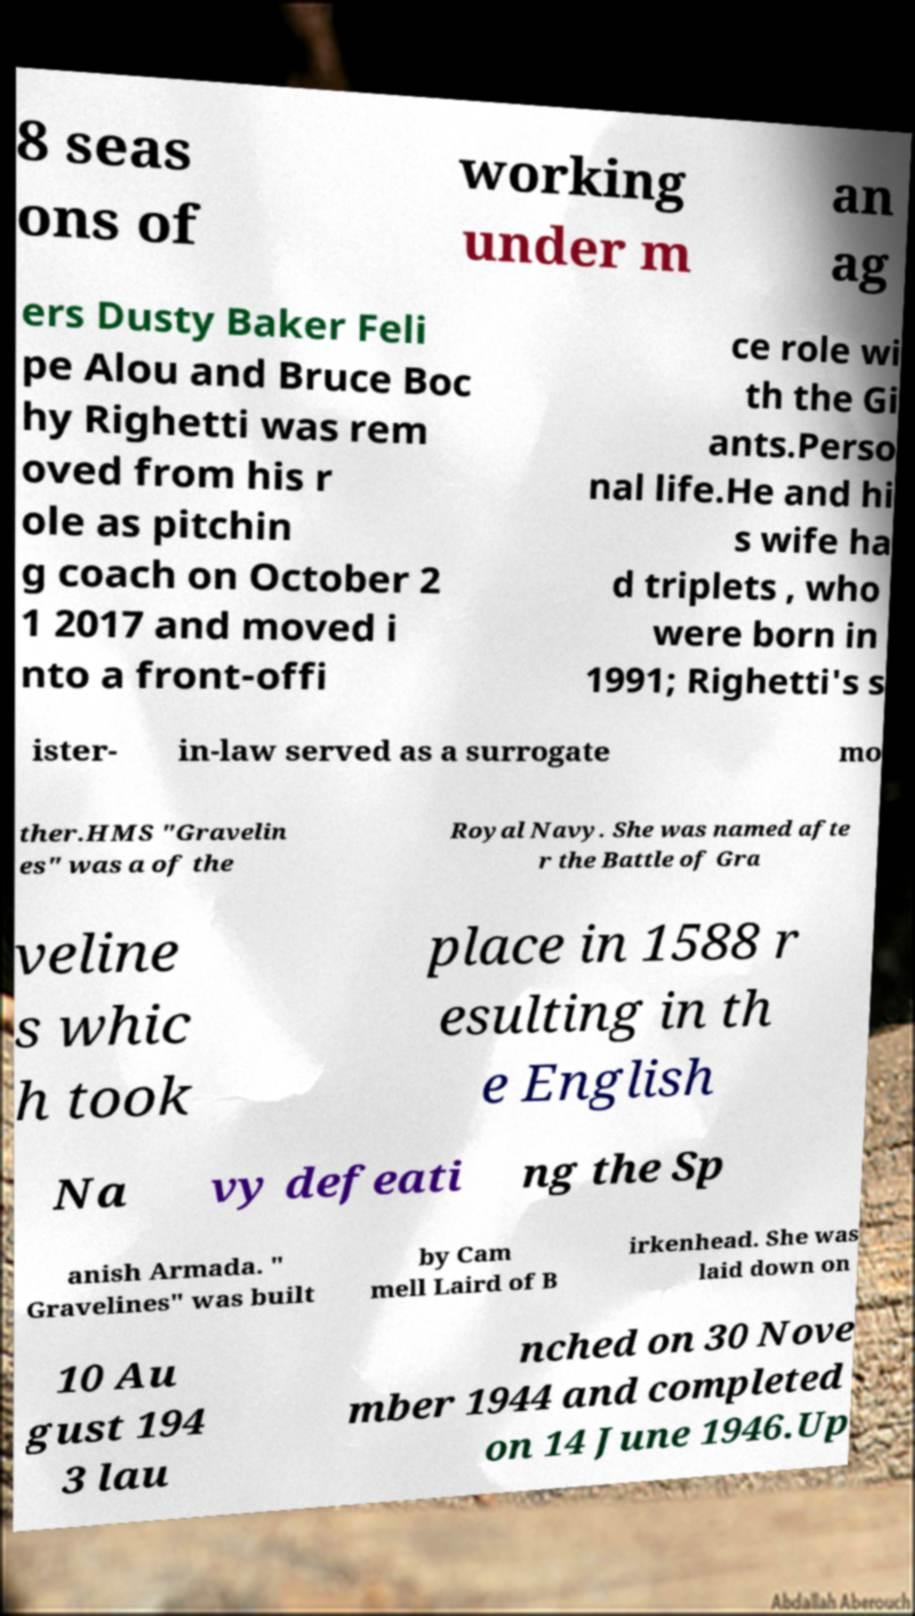For documentation purposes, I need the text within this image transcribed. Could you provide that? 8 seas ons of working under m an ag ers Dusty Baker Feli pe Alou and Bruce Boc hy Righetti was rem oved from his r ole as pitchin g coach on October 2 1 2017 and moved i nto a front-offi ce role wi th the Gi ants.Perso nal life.He and hi s wife ha d triplets , who were born in 1991; Righetti's s ister- in-law served as a surrogate mo ther.HMS "Gravelin es" was a of the Royal Navy. She was named afte r the Battle of Gra veline s whic h took place in 1588 r esulting in th e English Na vy defeati ng the Sp anish Armada. " Gravelines" was built by Cam mell Laird of B irkenhead. She was laid down on 10 Au gust 194 3 lau nched on 30 Nove mber 1944 and completed on 14 June 1946.Up 